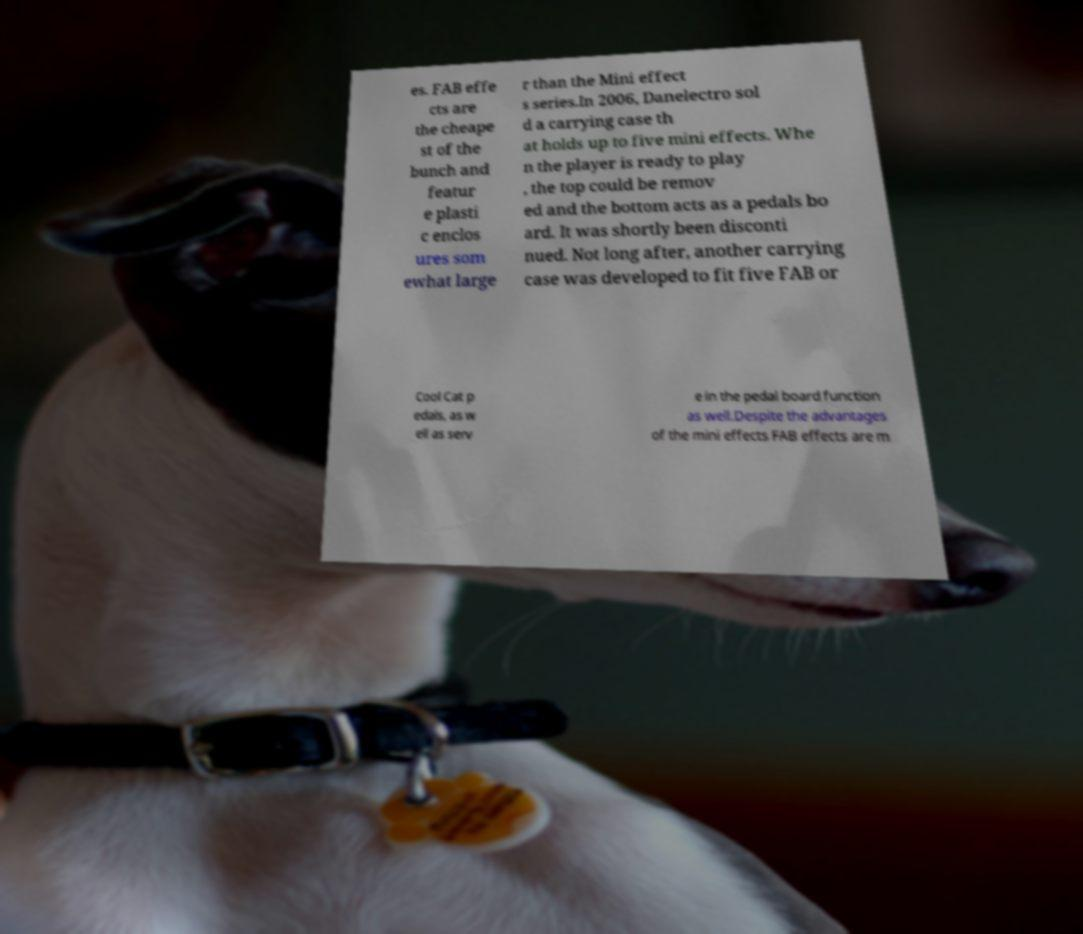Could you assist in decoding the text presented in this image and type it out clearly? es. FAB effe cts are the cheape st of the bunch and featur e plasti c enclos ures som ewhat large r than the Mini effect s series.In 2006, Danelectro sol d a carrying case th at holds up to five mini effects. Whe n the player is ready to play , the top could be remov ed and the bottom acts as a pedals bo ard. It was shortly been disconti nued. Not long after, another carrying case was developed to fit five FAB or Cool Cat p edals, as w ell as serv e in the pedal board function as well.Despite the advantages of the mini effects FAB effects are m 